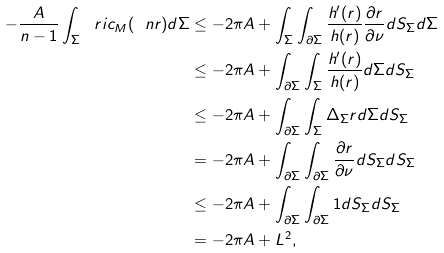<formula> <loc_0><loc_0><loc_500><loc_500>- \frac { A } { n - 1 } \int _ { \Sigma } \ r i c _ { M } ( \ n r ) d \Sigma & \leq - 2 \pi A + \int _ { \Sigma } \int _ { \partial \Sigma } \frac { h ^ { \prime } ( r ) } { h ( r ) } \frac { \partial r } { \partial \nu } d S _ { \Sigma } d \Sigma \\ & \leq - 2 \pi A + \int _ { \partial \Sigma } \int _ { \Sigma } \frac { h ^ { \prime } ( r ) } { h ( r ) } d \Sigma d S _ { \Sigma } \\ & \leq - 2 \pi A + \int _ { \partial \Sigma } \int _ { \Sigma } \Delta _ { \Sigma } r d \Sigma d S _ { \Sigma } \\ & = - 2 \pi A + \int _ { \partial \Sigma } \int _ { \partial \Sigma } \frac { \partial r } { \partial \nu } d S _ { \Sigma } d S _ { \Sigma } \\ & \leq - 2 \pi A + \int _ { \partial \Sigma } \int _ { \partial \Sigma } 1 d S _ { \Sigma } d S _ { \Sigma } \\ & = - 2 \pi A + L ^ { 2 } ,</formula> 